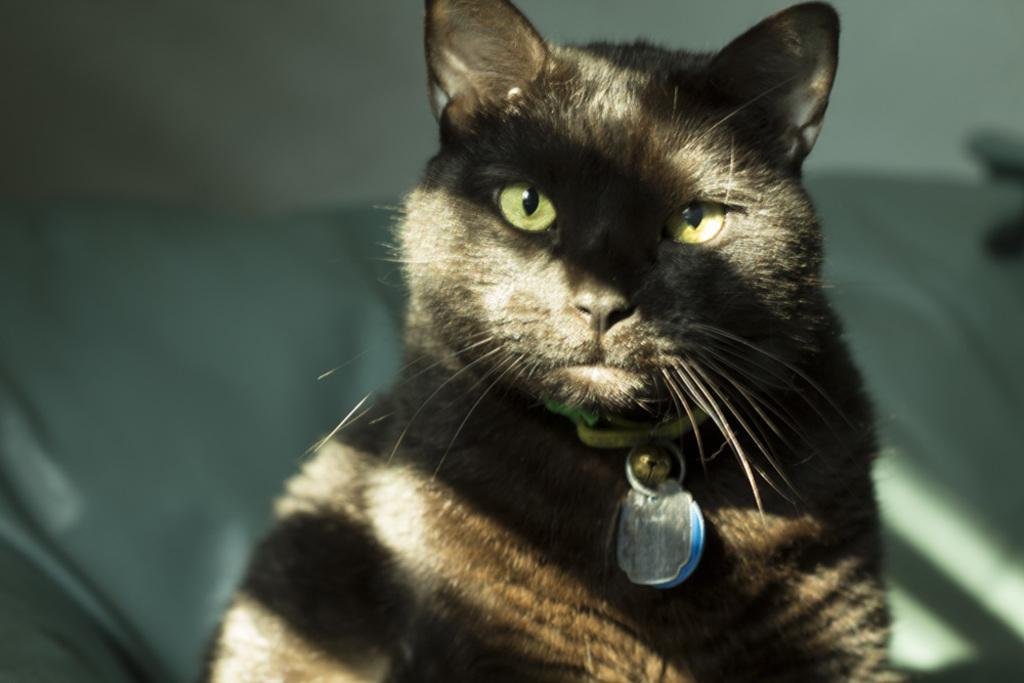How would you summarize this image in a sentence or two? In this picture there is a cat sitting on the sofa. At the back there is a wall. 